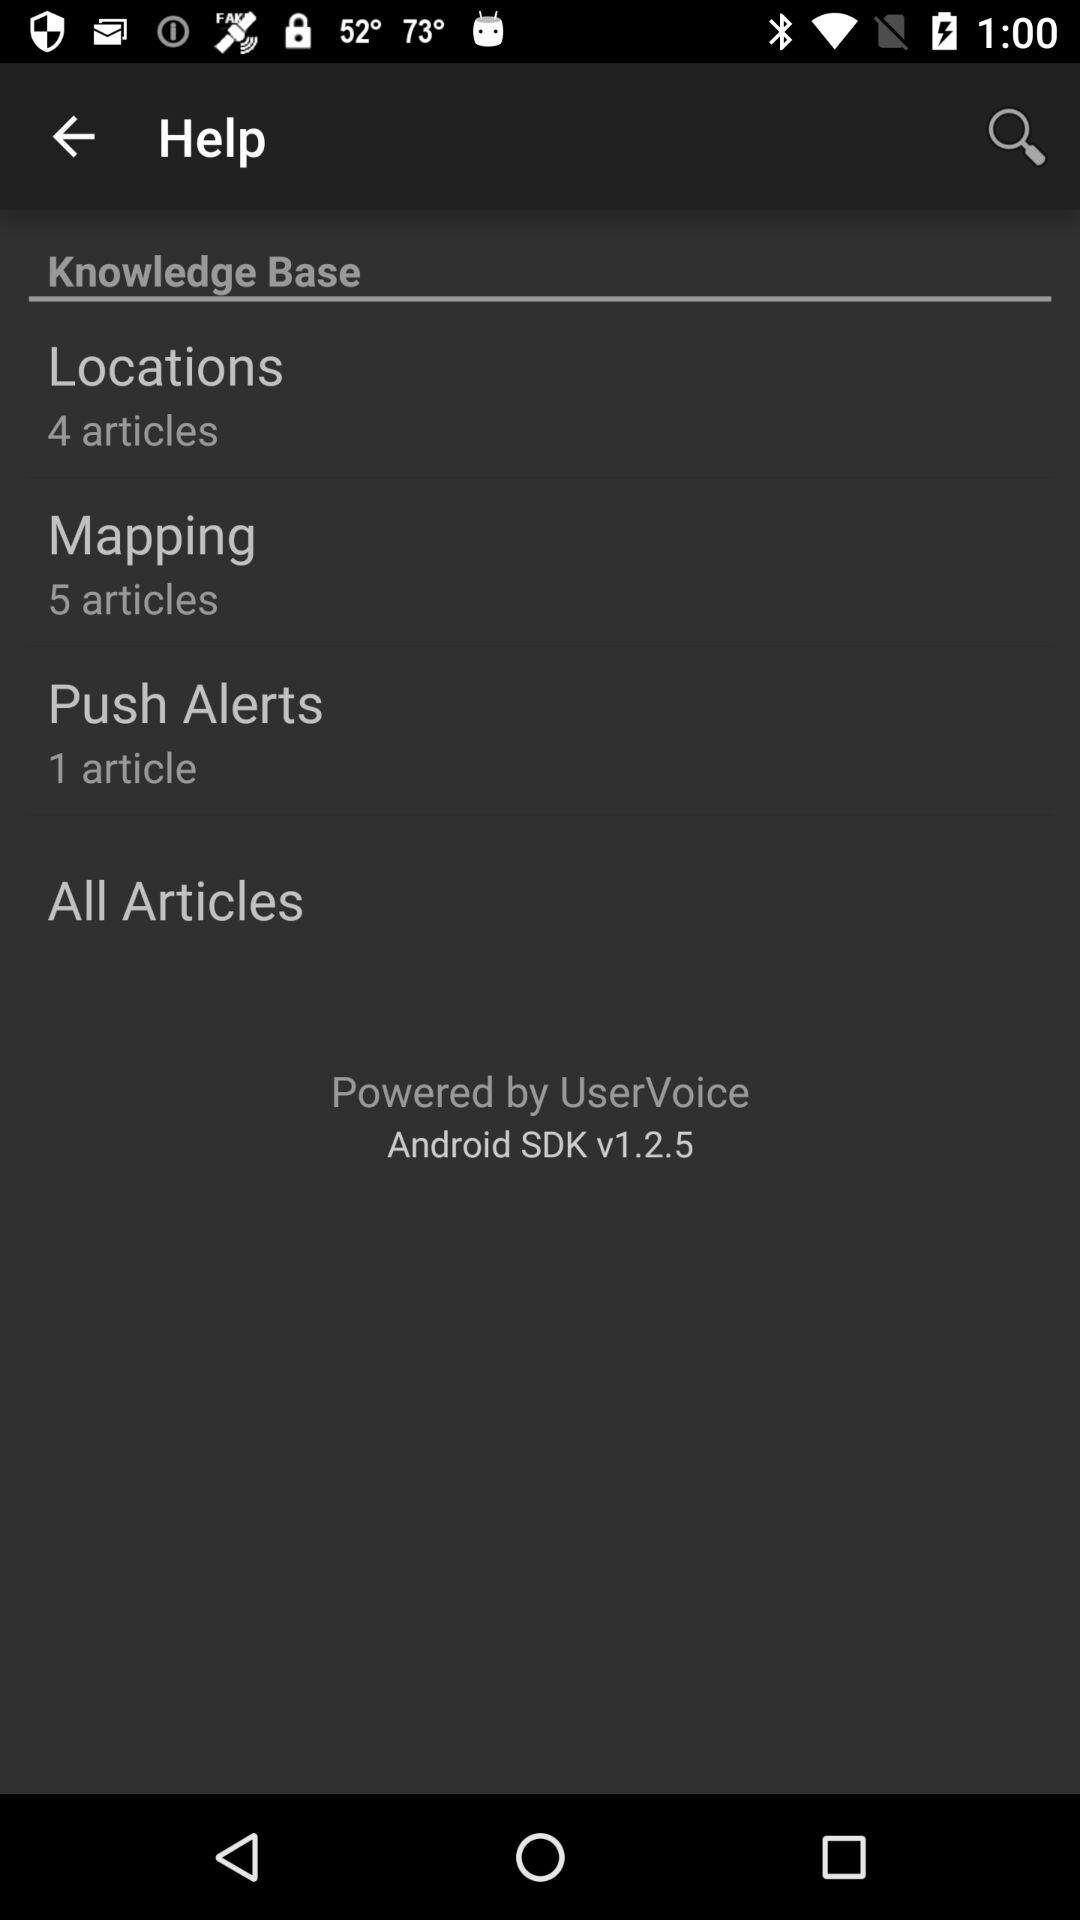How many articles are there in total?
Answer the question using a single word or phrase. 10 